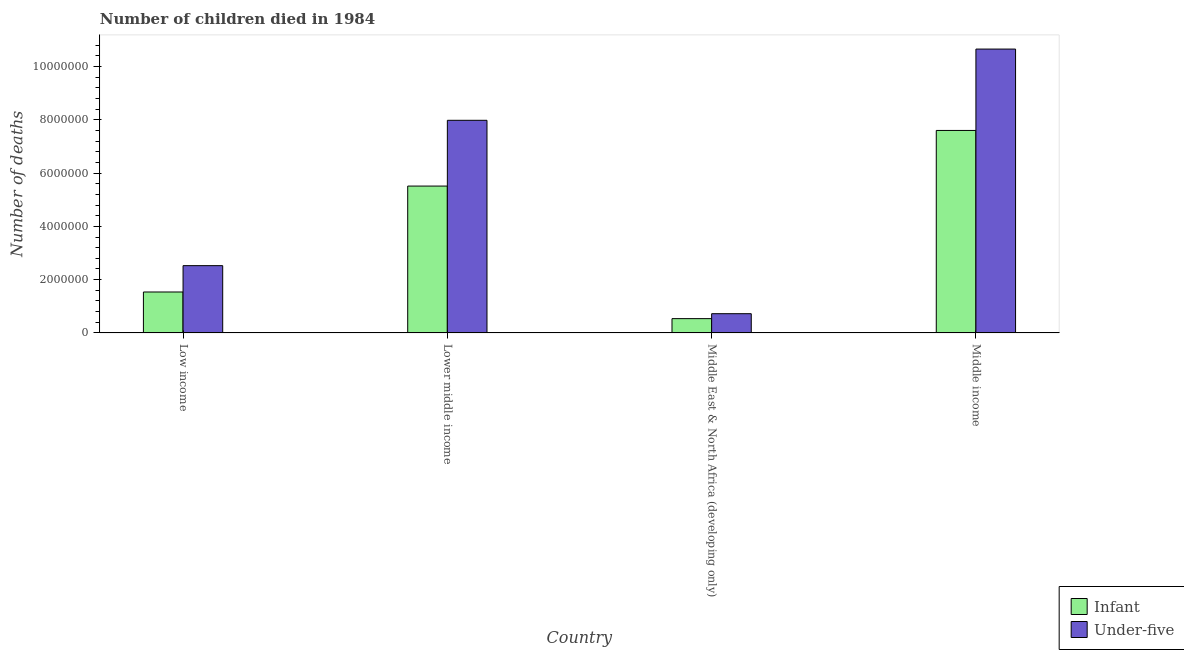Are the number of bars on each tick of the X-axis equal?
Offer a very short reply. Yes. How many bars are there on the 2nd tick from the left?
Ensure brevity in your answer.  2. How many bars are there on the 2nd tick from the right?
Offer a very short reply. 2. What is the number of under-five deaths in Middle income?
Keep it short and to the point. 1.07e+07. Across all countries, what is the maximum number of under-five deaths?
Your answer should be compact. 1.07e+07. Across all countries, what is the minimum number of infant deaths?
Your answer should be very brief. 5.37e+05. In which country was the number of infant deaths maximum?
Your response must be concise. Middle income. In which country was the number of infant deaths minimum?
Offer a terse response. Middle East & North Africa (developing only). What is the total number of infant deaths in the graph?
Make the answer very short. 1.52e+07. What is the difference between the number of infant deaths in Lower middle income and that in Middle East & North Africa (developing only)?
Provide a succinct answer. 4.98e+06. What is the difference between the number of under-five deaths in Middle income and the number of infant deaths in Middle East & North Africa (developing only)?
Offer a terse response. 1.01e+07. What is the average number of infant deaths per country?
Provide a short and direct response. 3.80e+06. What is the difference between the number of under-five deaths and number of infant deaths in Low income?
Your response must be concise. 9.89e+05. What is the ratio of the number of under-five deaths in Low income to that in Middle income?
Offer a terse response. 0.24. What is the difference between the highest and the second highest number of under-five deaths?
Your answer should be compact. 2.67e+06. What is the difference between the highest and the lowest number of infant deaths?
Offer a terse response. 7.06e+06. In how many countries, is the number of infant deaths greater than the average number of infant deaths taken over all countries?
Offer a very short reply. 2. What does the 2nd bar from the left in Middle income represents?
Provide a succinct answer. Under-five. What does the 2nd bar from the right in Middle income represents?
Ensure brevity in your answer.  Infant. How many bars are there?
Provide a succinct answer. 8. Are all the bars in the graph horizontal?
Give a very brief answer. No. How many countries are there in the graph?
Ensure brevity in your answer.  4. What is the difference between two consecutive major ticks on the Y-axis?
Your response must be concise. 2.00e+06. Are the values on the major ticks of Y-axis written in scientific E-notation?
Provide a short and direct response. No. Does the graph contain any zero values?
Keep it short and to the point. No. Does the graph contain grids?
Offer a very short reply. No. How are the legend labels stacked?
Make the answer very short. Vertical. What is the title of the graph?
Provide a succinct answer. Number of children died in 1984. What is the label or title of the X-axis?
Ensure brevity in your answer.  Country. What is the label or title of the Y-axis?
Your response must be concise. Number of deaths. What is the Number of deaths of Infant in Low income?
Make the answer very short. 1.54e+06. What is the Number of deaths in Under-five in Low income?
Your response must be concise. 2.53e+06. What is the Number of deaths in Infant in Lower middle income?
Ensure brevity in your answer.  5.51e+06. What is the Number of deaths in Under-five in Lower middle income?
Ensure brevity in your answer.  7.98e+06. What is the Number of deaths of Infant in Middle East & North Africa (developing only)?
Ensure brevity in your answer.  5.37e+05. What is the Number of deaths in Under-five in Middle East & North Africa (developing only)?
Ensure brevity in your answer.  7.23e+05. What is the Number of deaths in Infant in Middle income?
Provide a succinct answer. 7.60e+06. What is the Number of deaths of Under-five in Middle income?
Give a very brief answer. 1.07e+07. Across all countries, what is the maximum Number of deaths in Infant?
Provide a succinct answer. 7.60e+06. Across all countries, what is the maximum Number of deaths in Under-five?
Make the answer very short. 1.07e+07. Across all countries, what is the minimum Number of deaths of Infant?
Your answer should be very brief. 5.37e+05. Across all countries, what is the minimum Number of deaths of Under-five?
Ensure brevity in your answer.  7.23e+05. What is the total Number of deaths of Infant in the graph?
Provide a short and direct response. 1.52e+07. What is the total Number of deaths of Under-five in the graph?
Your response must be concise. 2.19e+07. What is the difference between the Number of deaths in Infant in Low income and that in Lower middle income?
Your response must be concise. -3.98e+06. What is the difference between the Number of deaths of Under-five in Low income and that in Lower middle income?
Provide a short and direct response. -5.46e+06. What is the difference between the Number of deaths of Infant in Low income and that in Middle East & North Africa (developing only)?
Keep it short and to the point. 1.00e+06. What is the difference between the Number of deaths of Under-five in Low income and that in Middle East & North Africa (developing only)?
Make the answer very short. 1.80e+06. What is the difference between the Number of deaths in Infant in Low income and that in Middle income?
Give a very brief answer. -6.06e+06. What is the difference between the Number of deaths of Under-five in Low income and that in Middle income?
Offer a terse response. -8.13e+06. What is the difference between the Number of deaths of Infant in Lower middle income and that in Middle East & North Africa (developing only)?
Your answer should be compact. 4.98e+06. What is the difference between the Number of deaths of Under-five in Lower middle income and that in Middle East & North Africa (developing only)?
Provide a succinct answer. 7.26e+06. What is the difference between the Number of deaths in Infant in Lower middle income and that in Middle income?
Provide a succinct answer. -2.09e+06. What is the difference between the Number of deaths of Under-five in Lower middle income and that in Middle income?
Give a very brief answer. -2.67e+06. What is the difference between the Number of deaths of Infant in Middle East & North Africa (developing only) and that in Middle income?
Your response must be concise. -7.06e+06. What is the difference between the Number of deaths of Under-five in Middle East & North Africa (developing only) and that in Middle income?
Provide a short and direct response. -9.93e+06. What is the difference between the Number of deaths of Infant in Low income and the Number of deaths of Under-five in Lower middle income?
Your answer should be very brief. -6.44e+06. What is the difference between the Number of deaths of Infant in Low income and the Number of deaths of Under-five in Middle East & North Africa (developing only)?
Make the answer very short. 8.15e+05. What is the difference between the Number of deaths in Infant in Low income and the Number of deaths in Under-five in Middle income?
Your response must be concise. -9.12e+06. What is the difference between the Number of deaths in Infant in Lower middle income and the Number of deaths in Under-five in Middle East & North Africa (developing only)?
Provide a succinct answer. 4.79e+06. What is the difference between the Number of deaths of Infant in Lower middle income and the Number of deaths of Under-five in Middle income?
Your answer should be compact. -5.14e+06. What is the difference between the Number of deaths in Infant in Middle East & North Africa (developing only) and the Number of deaths in Under-five in Middle income?
Keep it short and to the point. -1.01e+07. What is the average Number of deaths of Infant per country?
Offer a very short reply. 3.80e+06. What is the average Number of deaths in Under-five per country?
Your answer should be very brief. 5.47e+06. What is the difference between the Number of deaths in Infant and Number of deaths in Under-five in Low income?
Ensure brevity in your answer.  -9.89e+05. What is the difference between the Number of deaths of Infant and Number of deaths of Under-five in Lower middle income?
Your answer should be compact. -2.47e+06. What is the difference between the Number of deaths of Infant and Number of deaths of Under-five in Middle East & North Africa (developing only)?
Ensure brevity in your answer.  -1.86e+05. What is the difference between the Number of deaths of Infant and Number of deaths of Under-five in Middle income?
Keep it short and to the point. -3.05e+06. What is the ratio of the Number of deaths in Infant in Low income to that in Lower middle income?
Your answer should be compact. 0.28. What is the ratio of the Number of deaths of Under-five in Low income to that in Lower middle income?
Provide a short and direct response. 0.32. What is the ratio of the Number of deaths in Infant in Low income to that in Middle East & North Africa (developing only)?
Offer a very short reply. 2.86. What is the ratio of the Number of deaths in Under-five in Low income to that in Middle East & North Africa (developing only)?
Keep it short and to the point. 3.5. What is the ratio of the Number of deaths in Infant in Low income to that in Middle income?
Your answer should be very brief. 0.2. What is the ratio of the Number of deaths in Under-five in Low income to that in Middle income?
Give a very brief answer. 0.24. What is the ratio of the Number of deaths in Infant in Lower middle income to that in Middle East & North Africa (developing only)?
Offer a very short reply. 10.27. What is the ratio of the Number of deaths of Under-five in Lower middle income to that in Middle East & North Africa (developing only)?
Make the answer very short. 11.05. What is the ratio of the Number of deaths of Infant in Lower middle income to that in Middle income?
Your answer should be compact. 0.73. What is the ratio of the Number of deaths in Under-five in Lower middle income to that in Middle income?
Offer a terse response. 0.75. What is the ratio of the Number of deaths of Infant in Middle East & North Africa (developing only) to that in Middle income?
Offer a very short reply. 0.07. What is the ratio of the Number of deaths of Under-five in Middle East & North Africa (developing only) to that in Middle income?
Provide a short and direct response. 0.07. What is the difference between the highest and the second highest Number of deaths of Infant?
Your answer should be compact. 2.09e+06. What is the difference between the highest and the second highest Number of deaths of Under-five?
Provide a short and direct response. 2.67e+06. What is the difference between the highest and the lowest Number of deaths of Infant?
Your answer should be compact. 7.06e+06. What is the difference between the highest and the lowest Number of deaths of Under-five?
Provide a succinct answer. 9.93e+06. 